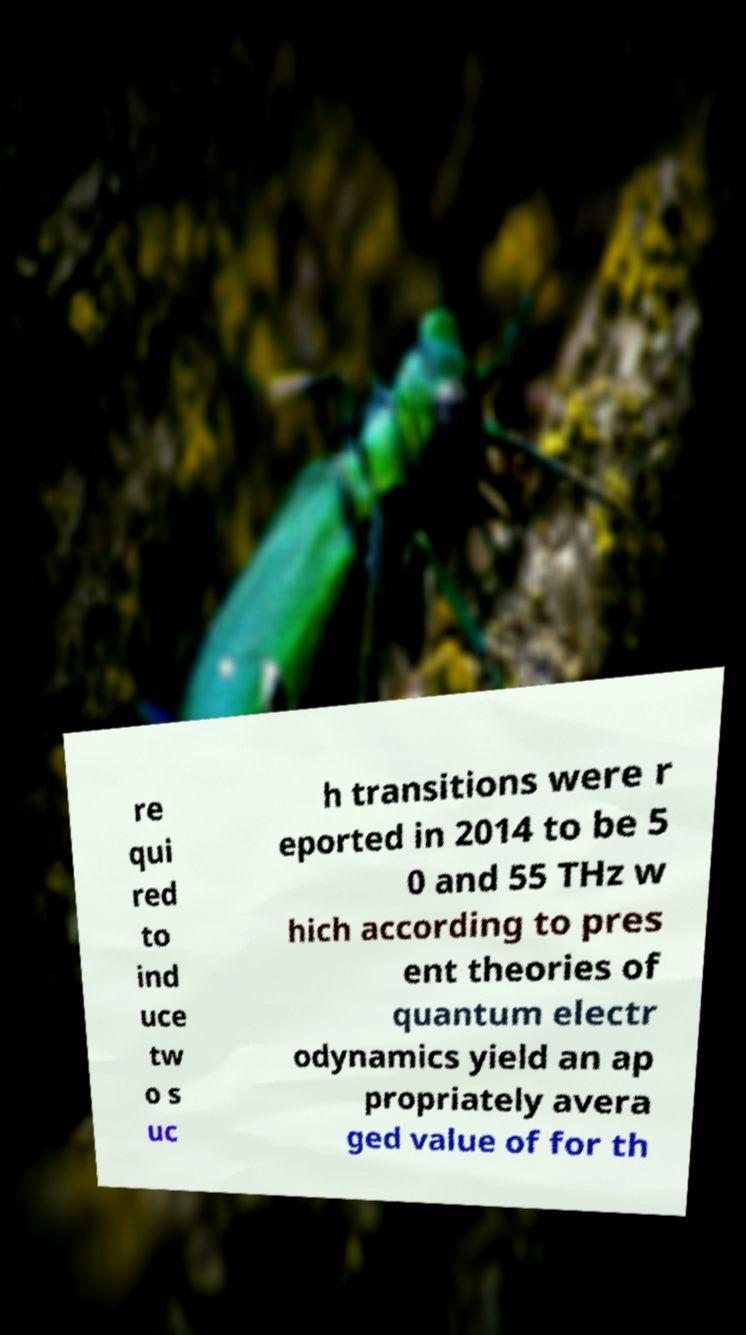What messages or text are displayed in this image? I need them in a readable, typed format. re qui red to ind uce tw o s uc h transitions were r eported in 2014 to be 5 0 and 55 THz w hich according to pres ent theories of quantum electr odynamics yield an ap propriately avera ged value of for th 